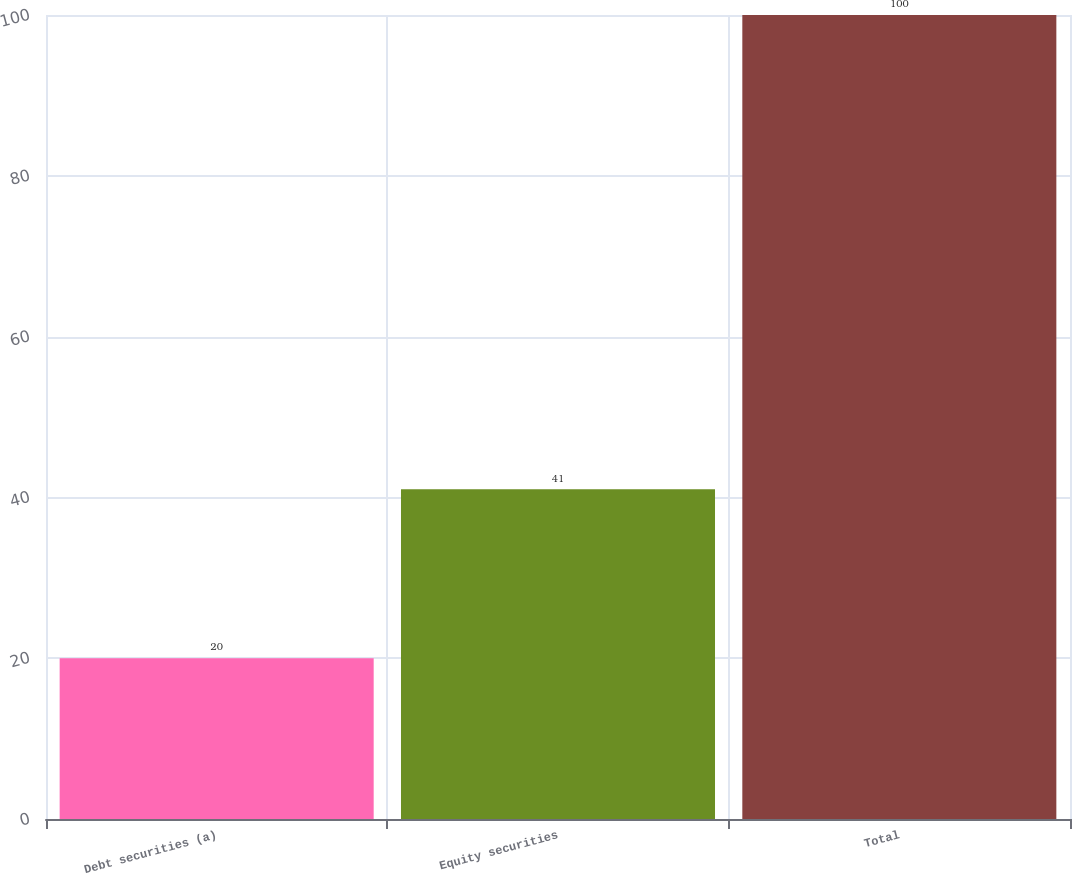Convert chart. <chart><loc_0><loc_0><loc_500><loc_500><bar_chart><fcel>Debt securities (a)<fcel>Equity securities<fcel>Total<nl><fcel>20<fcel>41<fcel>100<nl></chart> 